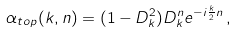<formula> <loc_0><loc_0><loc_500><loc_500>\alpha _ { t o p } ( k , n ) = ( 1 - D _ { k } ^ { 2 } ) D _ { k } ^ { n } e ^ { - i \frac { k } { 2 } n } \, ,</formula> 